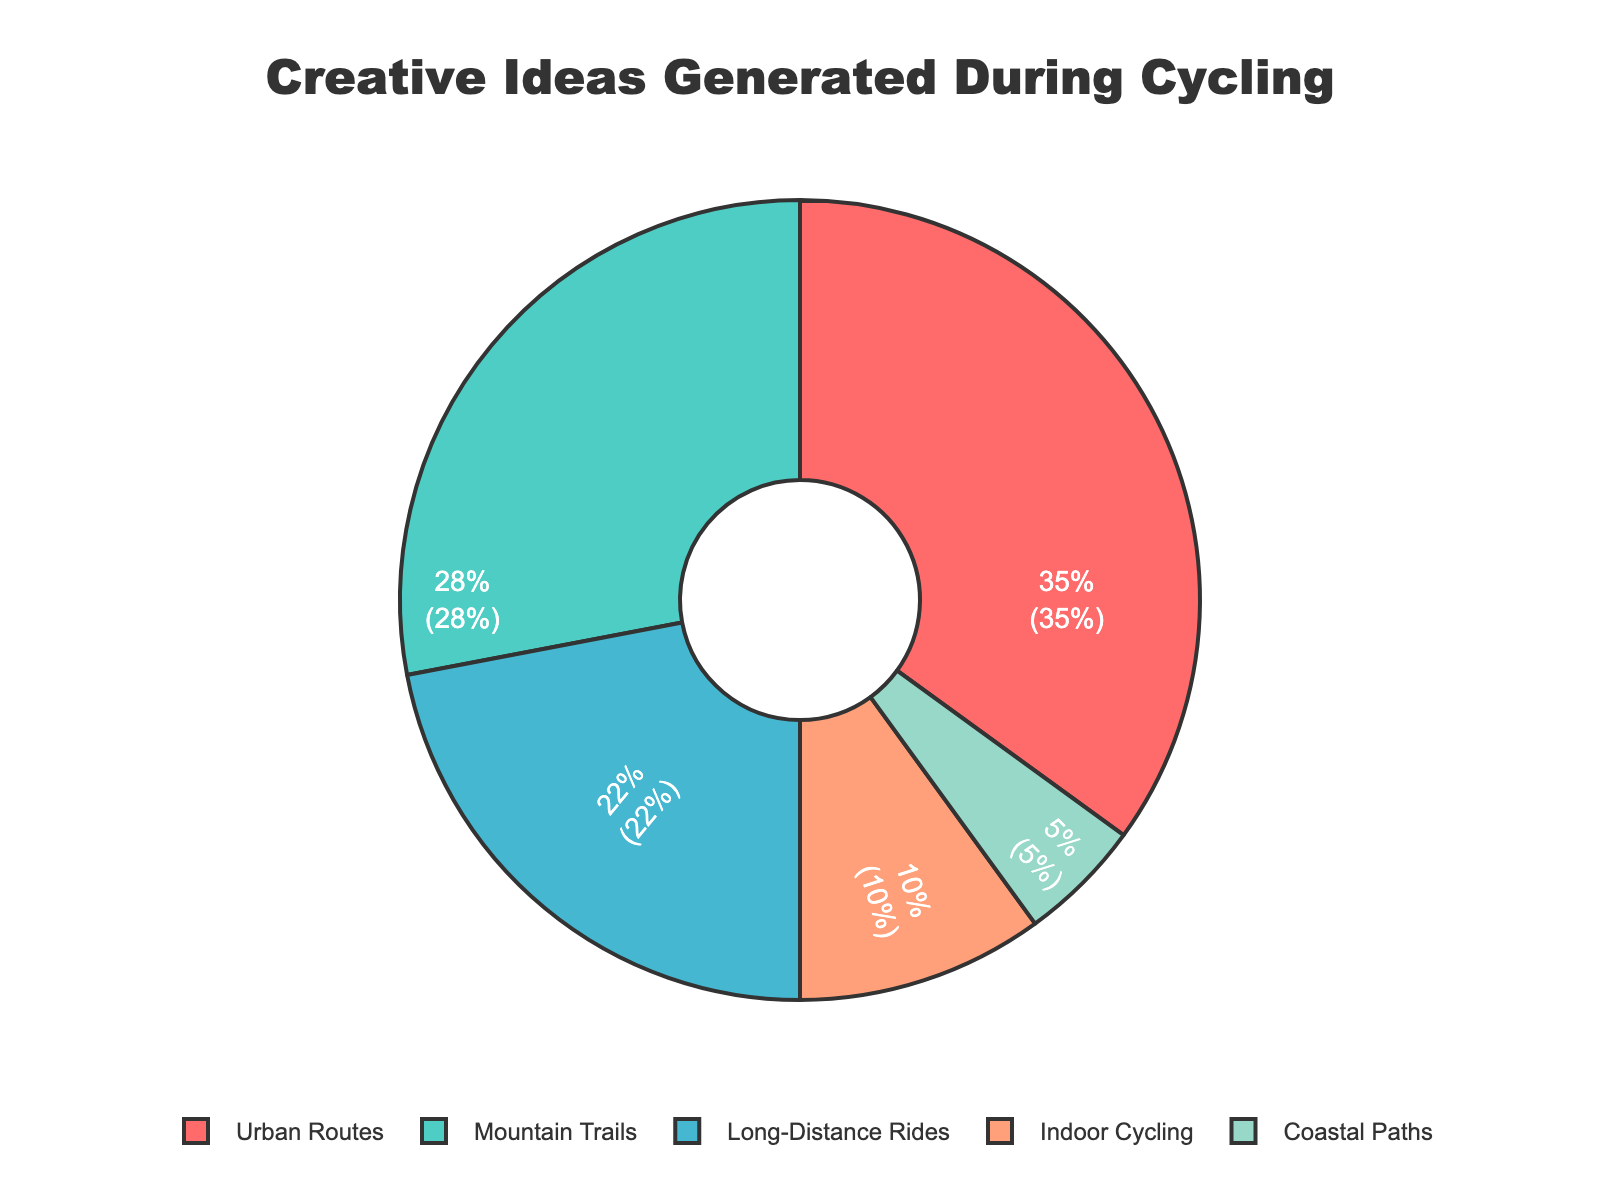What percentage of creative ideas are generated during Urban Routes? The segment labelled Urban Routes shows a percentage of 35% in the chart.
Answer: 35% Which cycling environment generates the least percentage of creative ideas? The Coastal Paths segment is the smallest in the chart, representing the smallest percentage of creative ideas generated.
Answer: Coastal Paths By how much do Mountain Trails surpass Indoor Cycling in terms of the percentage of creative ideas generated? Mountain Trails account for 28% while Indoor Cycling accounts for 10%. The difference is 28% - 10% = 18%.
Answer: 18% What is the combined percentage of creative ideas generated during Urban Routes and Long-Distance Rides? Urban Routes contribute 35% and Long-Distance Rides contribute 22%. The combined percentage is 35% + 22% = 57%.
Answer: 57% If you combine the percentages of Mountain Trails and Coastal Paths, will it exceed the percentage of Urban Routes? Mountain Trails and Coastal Paths have 28% + 5% = 33%, while Urban Routes have 35%. Therefore, 33% does not exceed 35%.
Answer: No What’s the ratio of creative ideas generated during Long-Distance Rides to Indoor Cycling? Long-Distance Rides account for 22%, and Indoor Cycling accounts for 10%. The ratio is 22:10, which simplifies to 11:5.
Answer: 11:5 Which environment generates more creative ideas: Mountain Trails or long-distance rides? The chart shows Mountain Trails contribute 28%, whereas Long-Distance Rides contribute 22%. Thus, Mountain Trails generate more creative ideas.
Answer: Mountain Trails If the percentages of Urban Routes and Mountain Trails were averaged, what would the result be? Urban Routes have 35%, and Mountain Trails have 28%. The average of these is (35% + 28%) / 2 = 31.5%.
Answer: 31.5% Is the percentage of creative ideas generated in Coastal Paths less than the sum of those generated in Indoor Cycling and Long-Distance Rides? Coastal Paths have 5%, Indoor Cycling has 10%, and Long-Distance Rides have 22%. The sum of Indoor Cycling and Long-Distance Rides is 10% + 22% = 32%, which is more than 5%.
Answer: Yes 